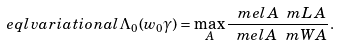<formula> <loc_0><loc_0><loc_500><loc_500>\ e q l { v a r i a t i o n a l } \Lambda _ { 0 } ( w _ { 0 } \gamma ) = \max _ { A } \frac { \ m e l { A } { \ m L \, } { A } } { \ m e l { A } { \ m W } { A } } .</formula> 